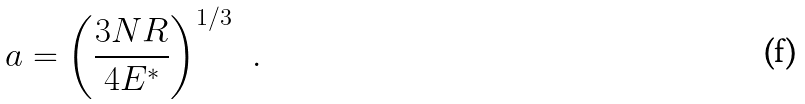Convert formula to latex. <formula><loc_0><loc_0><loc_500><loc_500>a = \left ( \frac { 3 N R } { 4 E ^ { * } } \right ) ^ { 1 / 3 } \ \ .</formula> 